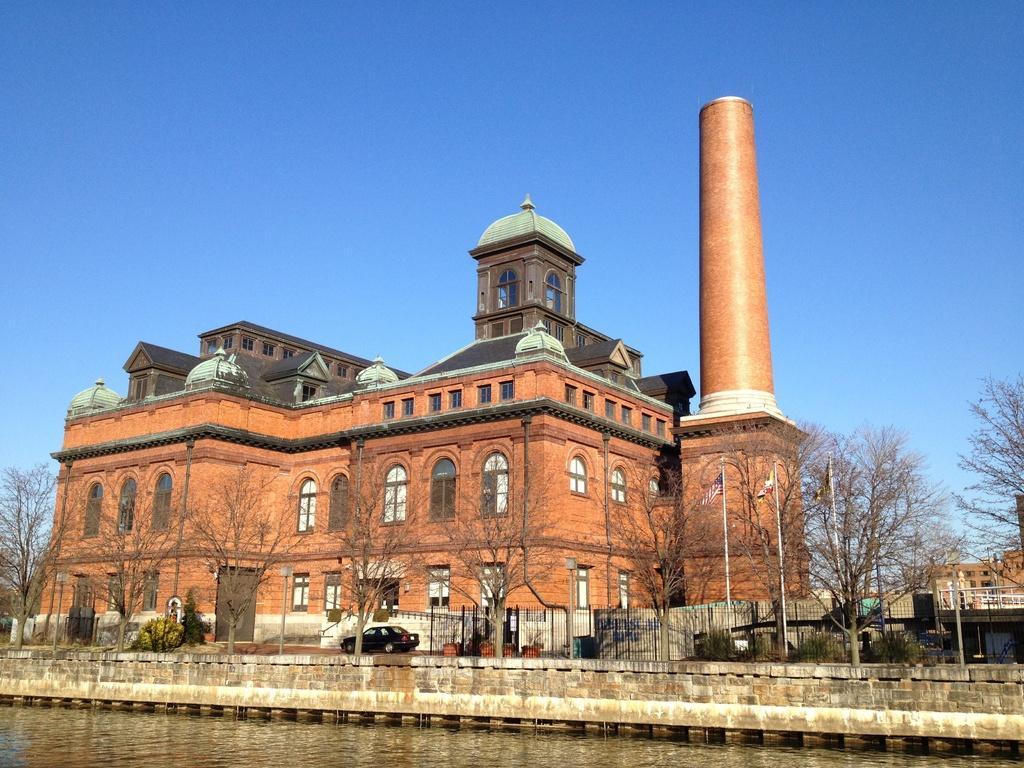Can you describe this image briefly? In this image we can see a building which is in orange color. In front of it trees are present. Bottom of the image lake is there and fencing is there. Behind the fencing one car is present. 